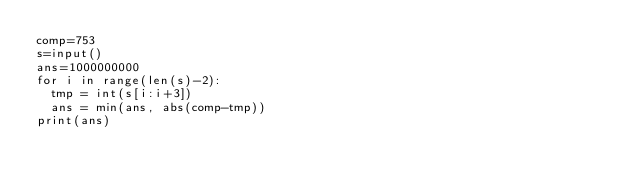Convert code to text. <code><loc_0><loc_0><loc_500><loc_500><_Python_>comp=753
s=input()
ans=1000000000
for i in range(len(s)-2):
  tmp = int(s[i:i+3])
  ans = min(ans, abs(comp-tmp))
print(ans)</code> 